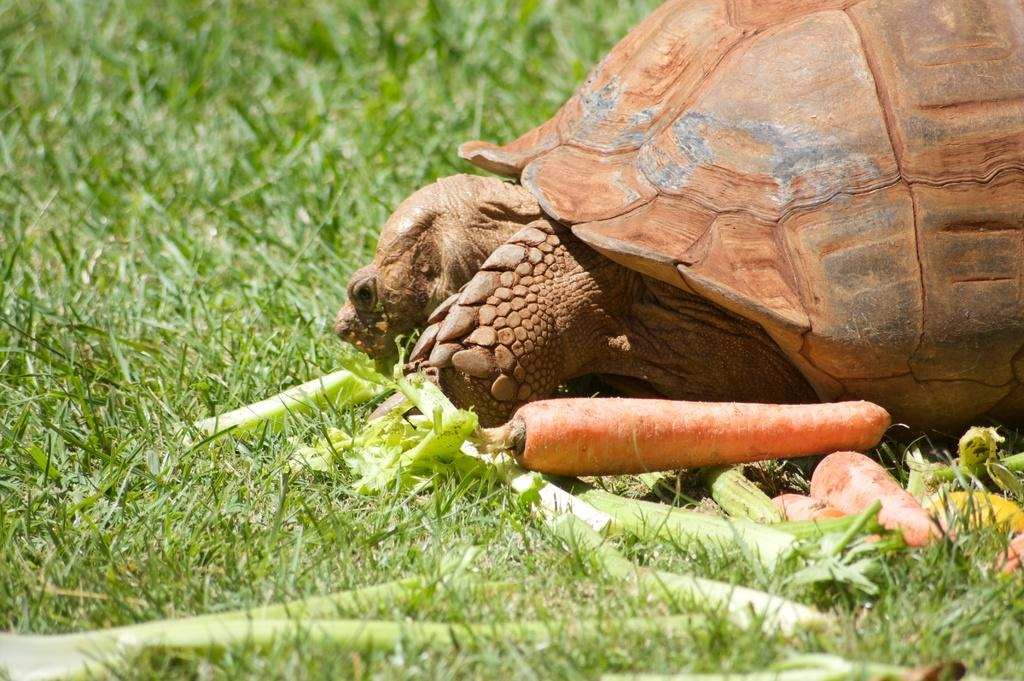What type of animal is in the image? There is a tortoise in the image. What else can be seen in the image besides the tortoise? There are vegetables and grass in the image. What is the primary vegetation in the image? The land is covered with grass. How close are the vegetables to the tortoise? The vegetables are near the tortoise. What type of harbor can be seen in the image? There is no harbor present in the image; it features a tortoise, vegetables, and grass. How does the tortoise draw attention to itself in the image? The tortoise does not actively draw attention to itself in the image; it is simply present among the other elements. 